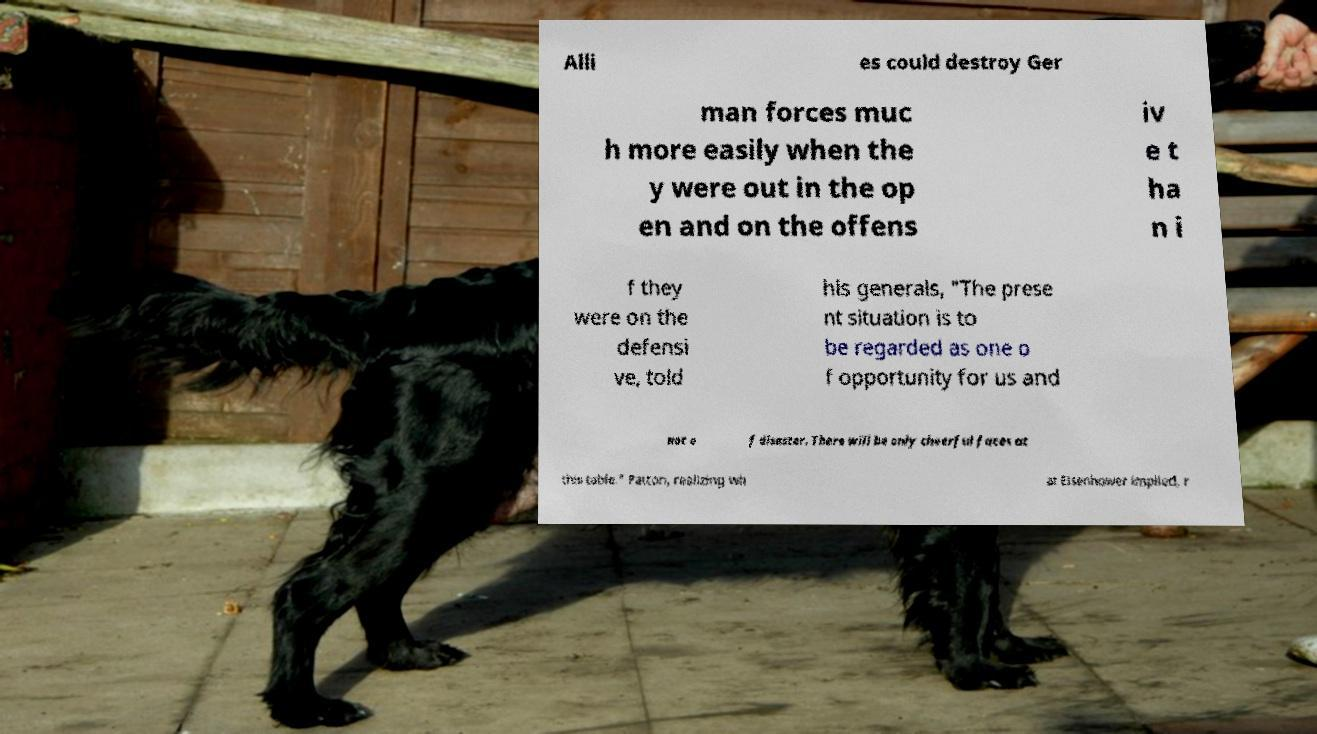For documentation purposes, I need the text within this image transcribed. Could you provide that? Alli es could destroy Ger man forces muc h more easily when the y were out in the op en and on the offens iv e t ha n i f they were on the defensi ve, told his generals, "The prese nt situation is to be regarded as one o f opportunity for us and not o f disaster. There will be only cheerful faces at this table." Patton, realizing wh at Eisenhower implied, r 